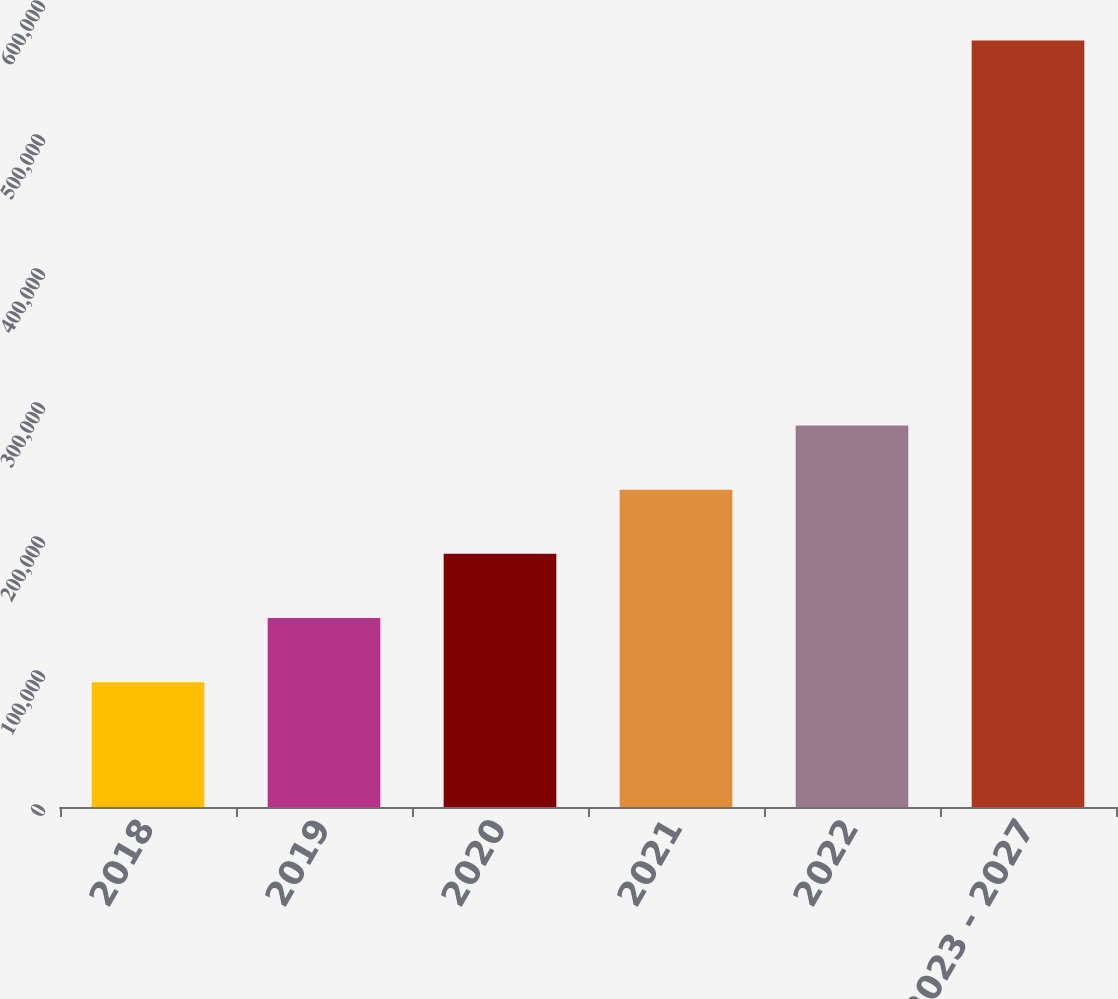Convert chart. <chart><loc_0><loc_0><loc_500><loc_500><bar_chart><fcel>2018<fcel>2019<fcel>2020<fcel>2021<fcel>2022<fcel>2023 - 2027<nl><fcel>93155<fcel>141032<fcel>188909<fcel>236786<fcel>284663<fcel>571926<nl></chart> 